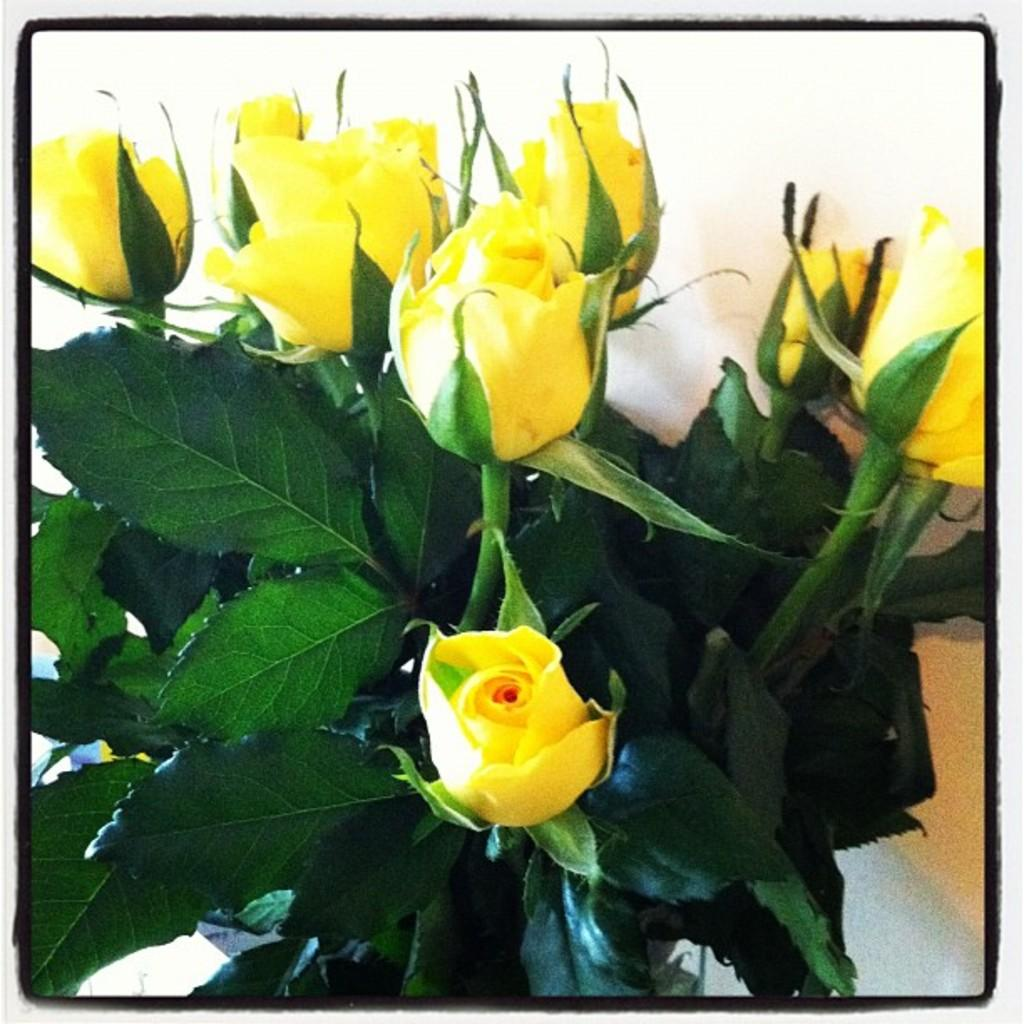What type of flowers are present in the image? There are yellow rose flowers in the image. What color are the leaves in the image? There are green leaves in the image. What type of needle can be seen piercing through the flowers in the image? There is no needle present in the image; it only features yellow rose flowers and green leaves. What type of beast is hiding behind the leaves in the image? There is no beast present in the image; it only features yellow rose flowers and green leaves. 